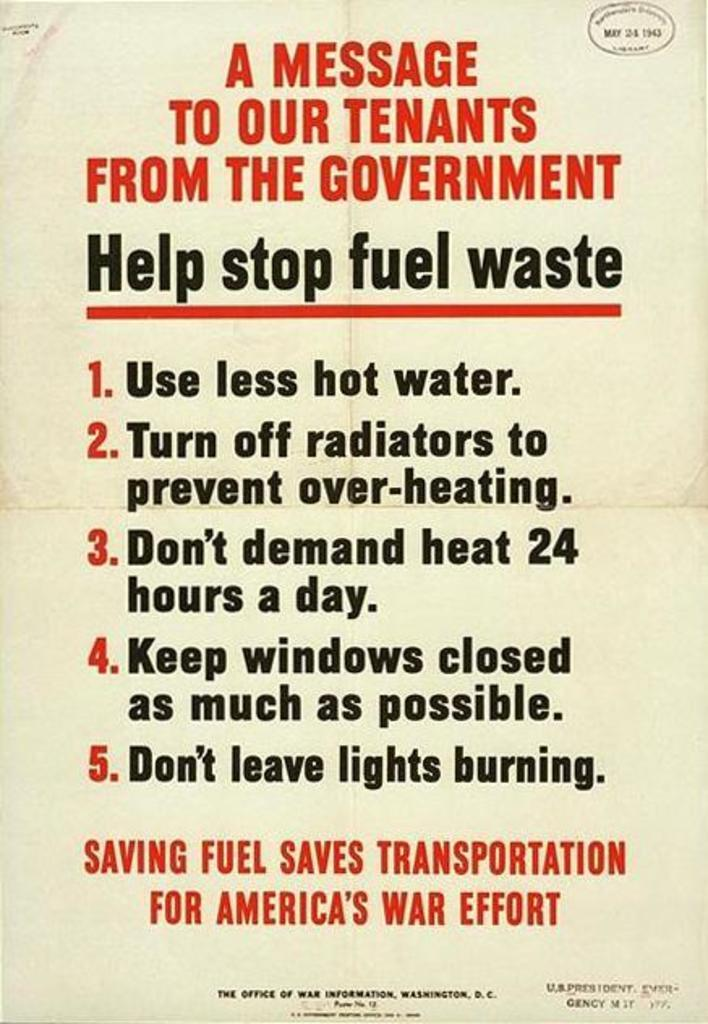<image>
Share a concise interpretation of the image provided. A message to tenants from the government to help stop fuel waste. 